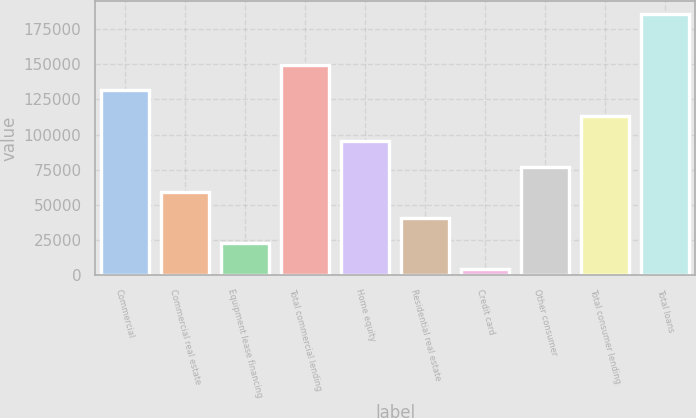<chart> <loc_0><loc_0><loc_500><loc_500><bar_chart><fcel>Commercial<fcel>Commercial real estate<fcel>Equipment lease financing<fcel>Total commercial lending<fcel>Home equity<fcel>Residential real estate<fcel>Credit card<fcel>Other consumer<fcel>Total consumer lending<fcel>Total loans<nl><fcel>131390<fcel>58768.9<fcel>22458.3<fcel>149545<fcel>95079.5<fcel>40613.6<fcel>4303<fcel>76924.2<fcel>113235<fcel>185856<nl></chart> 